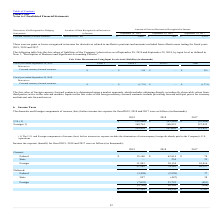From Plexus's financial document, Which years does the table provide information for the Income tax expense (benefit)? The document contains multiple relevant values: 2019, 2018, 2017. From the document: "ptember 28, 2019 September 29, 2018 September 30, 2017 September 28, 2019 September 29, 2018 September 30, 2017 September 28, 2019 September 29, 2018 ..." Also, What was the current federal income tax expense  in 2017? According to the financial document, 78 (in thousands). The relevant text states: "Federal $ 15,160 $ 63,814 $ 78..." Also, What was the deferred federal income tax expense  in 2018? According to the financial document, (2,958) (in thousands). The relevant text states: "Federal (3,498) (2,958) 77..." Also, How many years did the total income tax expense exceed $50,000 thousand? Based on the analysis, there are 1 instances. The counting process: 2018. Also, can you calculate: What was the change in the total current income tax expense between 2017 and 2018? Based on the calculation: 74,182-10,127, the result is 64055 (in thousands). This is based on the information: "27,103 74,182 10,127 27,103 74,182 10,127..." The key data points involved are: 10,127, 74,182. Also, can you calculate: What was the percentage change in the deferred State income tax expense between 2017 and 2019? To answer this question, I need to perform calculations using the financial data. The calculation is: (827-38)/38, which equals 2076.32 (percentage). This is based on the information: "State 827 (447) 38 State 827 (447) 38..." The key data points involved are: 38, 827. 